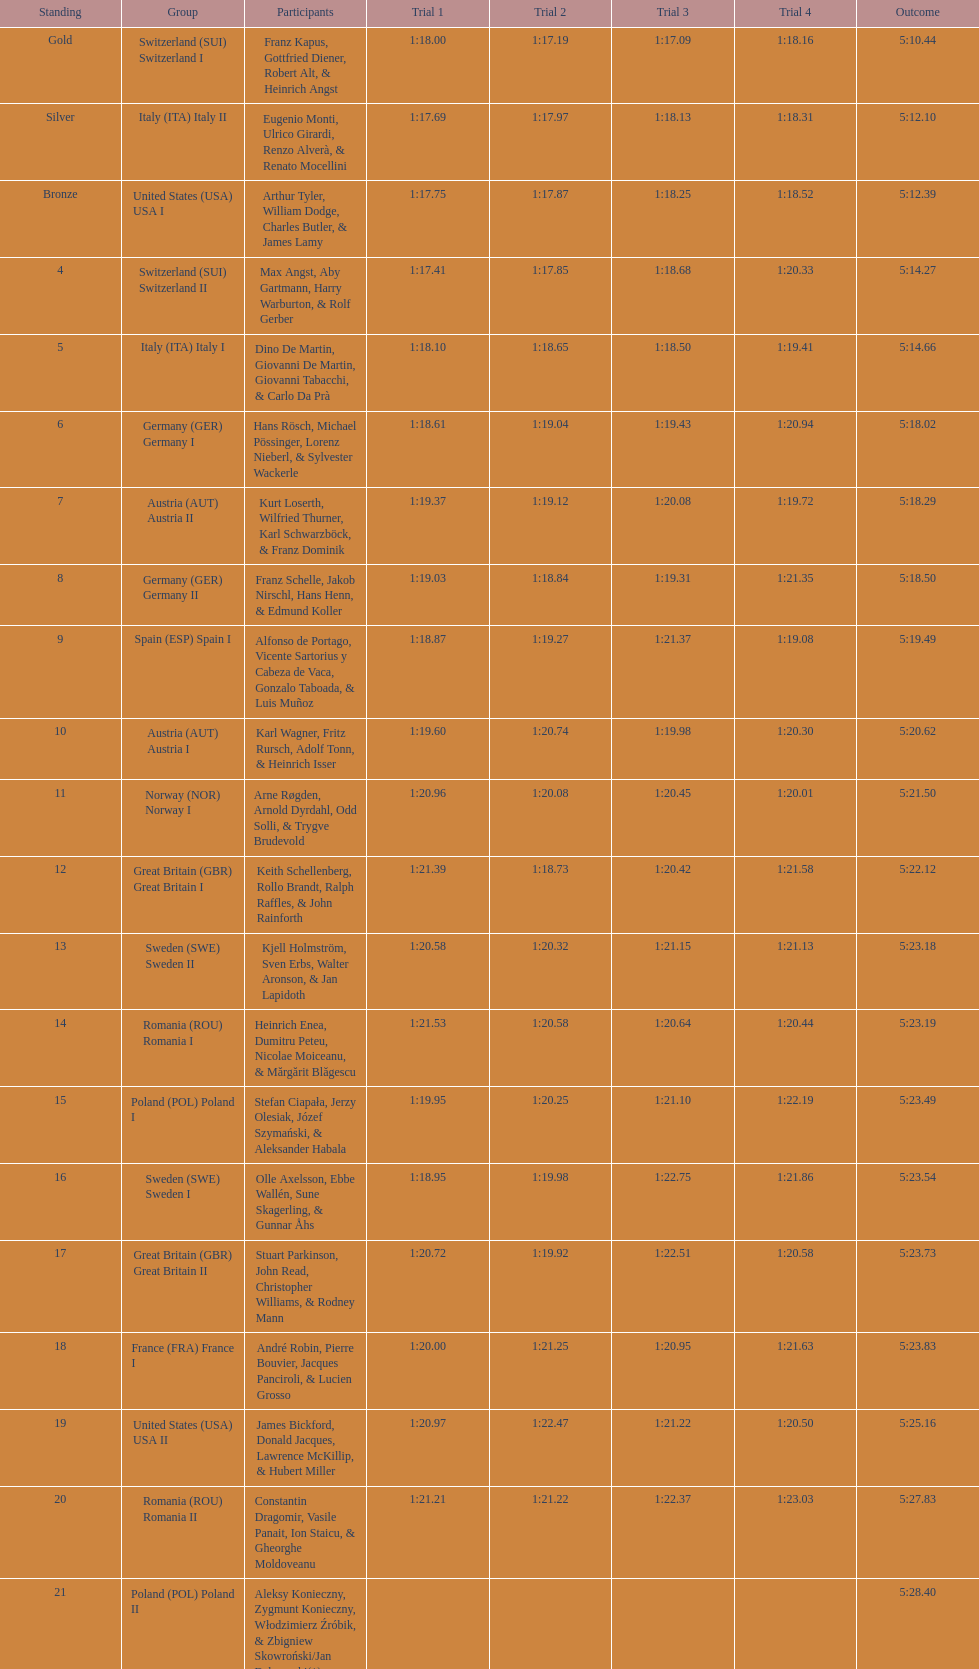What team came in second to last place? Romania. 